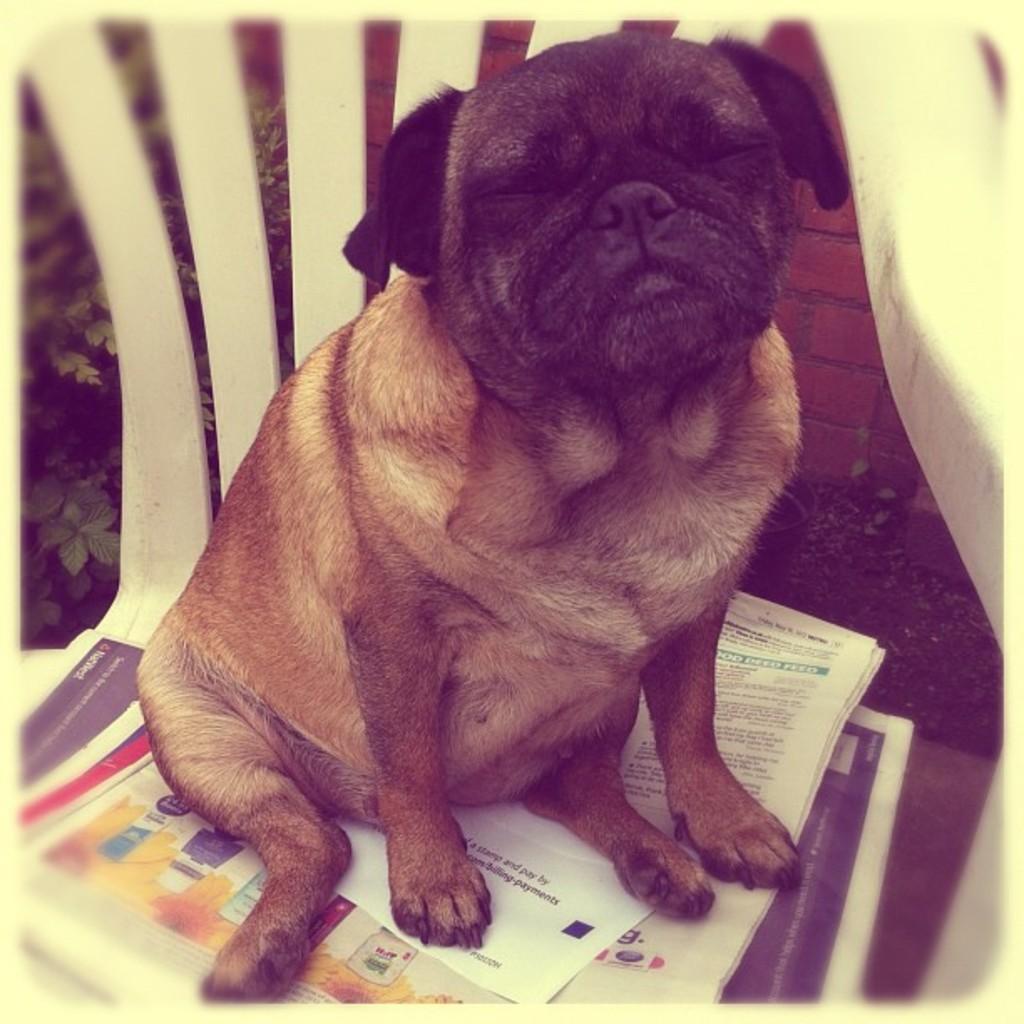How would you summarize this image in a sentence or two? In the background there is a plant with leaves and stems. There are a few little plants and there is a wall. In the middle of the image there is a chair with a few papers on it and there is a dog on the chair. 